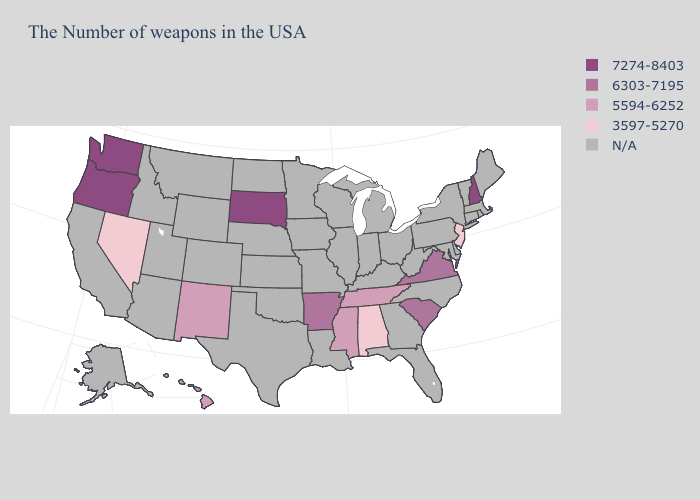Does South Carolina have the lowest value in the USA?
Give a very brief answer. No. Name the states that have a value in the range 5594-6252?
Short answer required. Tennessee, Mississippi, New Mexico, Hawaii. Name the states that have a value in the range 5594-6252?
Write a very short answer. Tennessee, Mississippi, New Mexico, Hawaii. What is the value of Illinois?
Concise answer only. N/A. Does the map have missing data?
Write a very short answer. Yes. Name the states that have a value in the range N/A?
Short answer required. Maine, Massachusetts, Rhode Island, Vermont, Connecticut, New York, Delaware, Maryland, Pennsylvania, North Carolina, West Virginia, Ohio, Florida, Georgia, Michigan, Kentucky, Indiana, Wisconsin, Illinois, Louisiana, Missouri, Minnesota, Iowa, Kansas, Nebraska, Oklahoma, Texas, North Dakota, Wyoming, Colorado, Utah, Montana, Arizona, Idaho, California, Alaska. Name the states that have a value in the range 7274-8403?
Keep it brief. New Hampshire, South Dakota, Washington, Oregon. Name the states that have a value in the range 7274-8403?
Write a very short answer. New Hampshire, South Dakota, Washington, Oregon. Among the states that border Montana , which have the lowest value?
Write a very short answer. South Dakota. What is the value of Nevada?
Be succinct. 3597-5270. What is the value of Georgia?
Short answer required. N/A. How many symbols are there in the legend?
Short answer required. 5. What is the value of Idaho?
Give a very brief answer. N/A. 